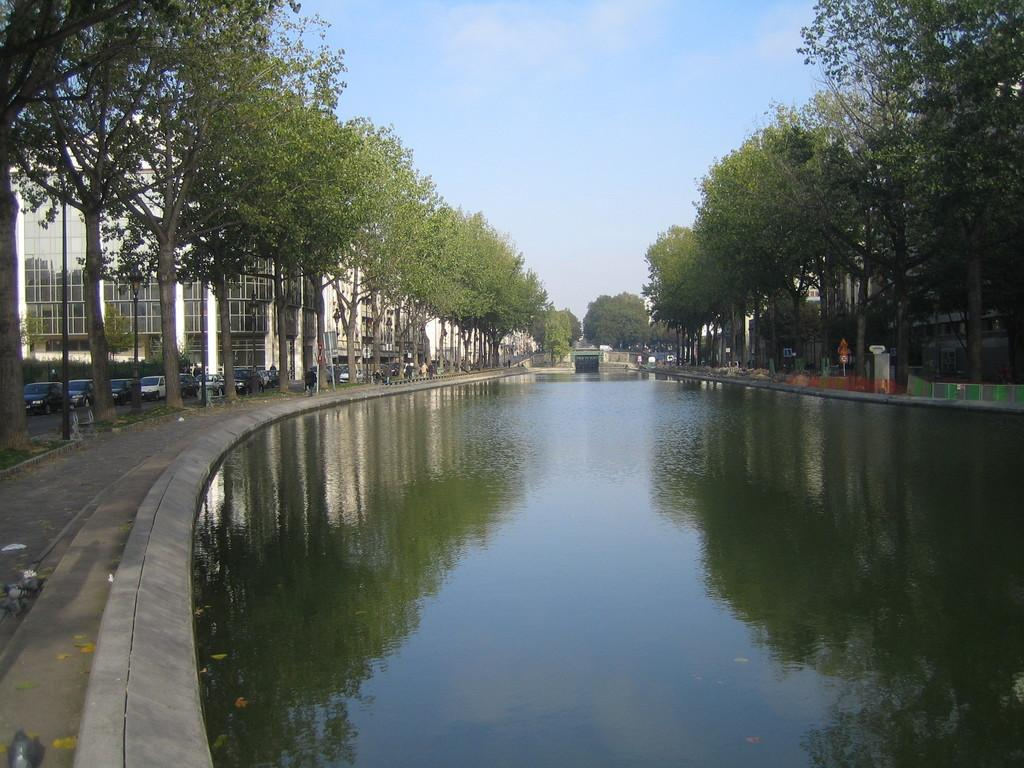What type of natural element can be seen in the image? Water is visible in the image. What type of surface is present in the image? There is ground visible in the image. What type of vegetation is present in the image? There are trees in the image. What type of man-made structure is present in the image? There are boards and a bridge in the image. What type of transportation is present in the image? There are vehicles on the road in the image. What type of human-made structures are present in the image? There are buildings in the image. What is visible in the background of the image? The sky is visible in the background of the image. Can you see a rose growing near the bridge in the image? There is no rose visible in the image. Is there a boy playing near the vehicles in the image? There is no boy present in the image. 